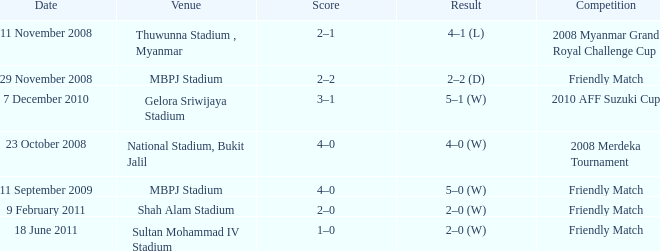What is the Result of the Competition at MBPJ Stadium with a Score of 4–0? 5–0 (W). 